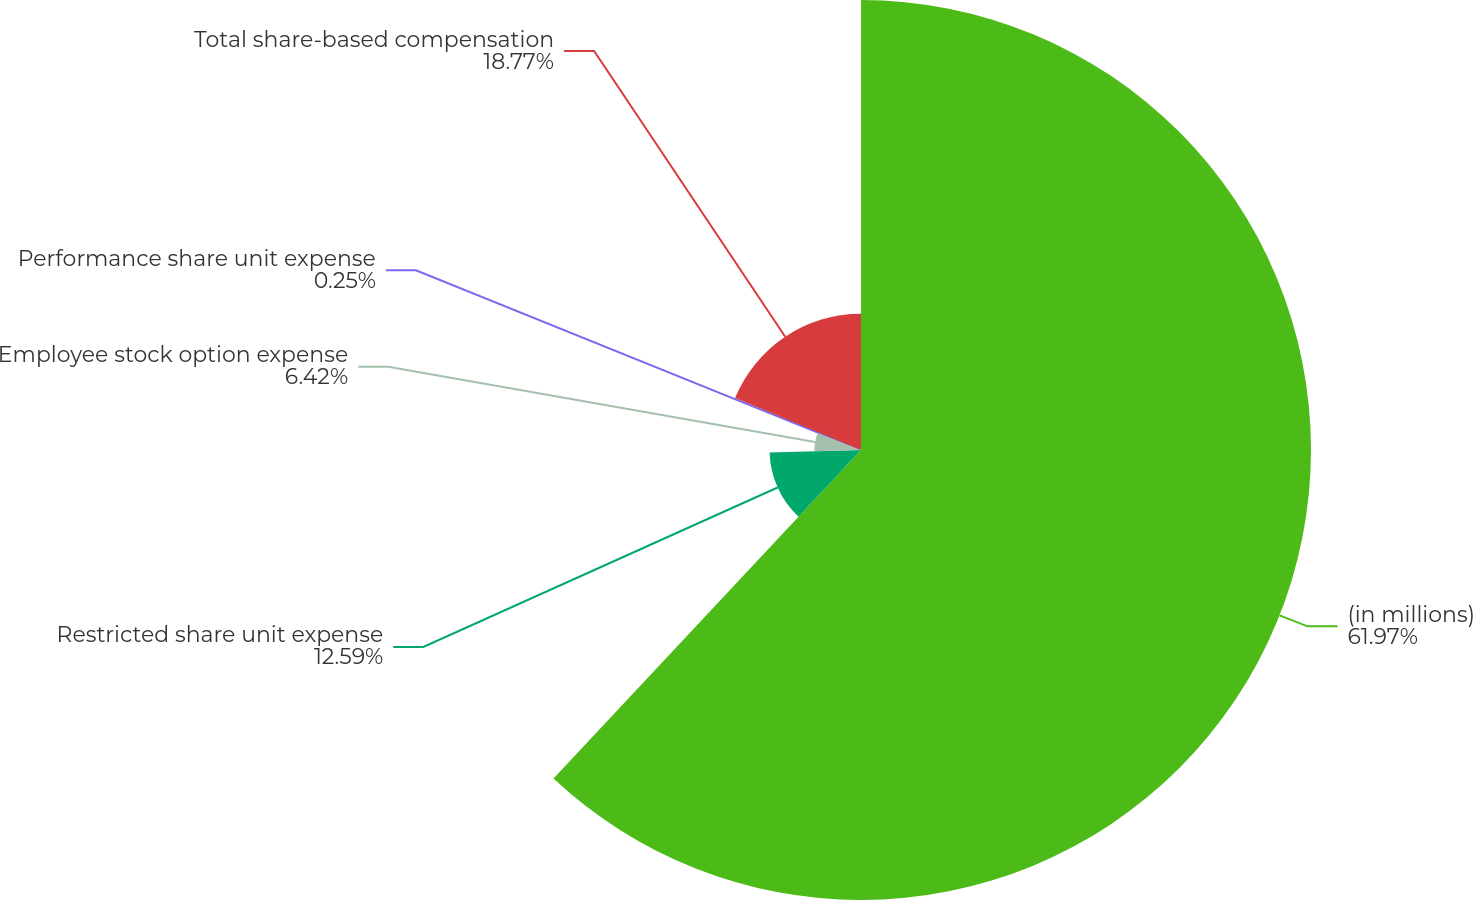Convert chart to OTSL. <chart><loc_0><loc_0><loc_500><loc_500><pie_chart><fcel>(in millions)<fcel>Restricted share unit expense<fcel>Employee stock option expense<fcel>Performance share unit expense<fcel>Total share-based compensation<nl><fcel>61.98%<fcel>12.59%<fcel>6.42%<fcel>0.25%<fcel>18.77%<nl></chart> 